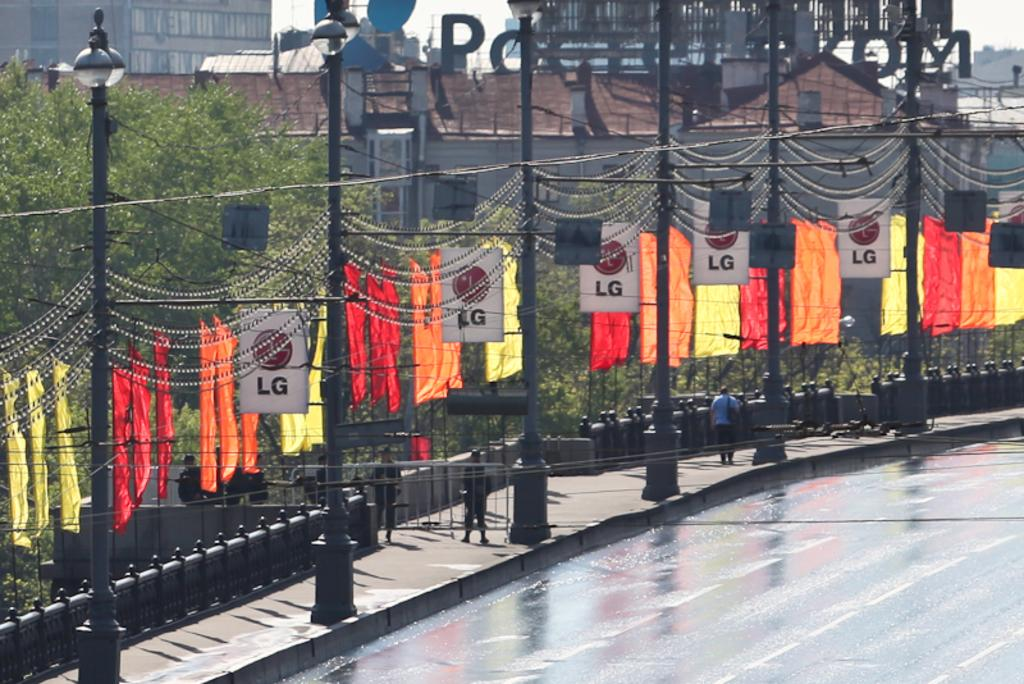What type of structures are present in the image? There are light poles, flags, and hoardings in the image. Are there any living beings in the image? Yes, there are people in the image. What can be seen in the background of the image? There are buildings with windows and trees in the background of the image. What type of bag is the parent carrying in the image? There is no parent or bag present in the image. Where is the mailbox located in the image? There is no mailbox present in the image. 